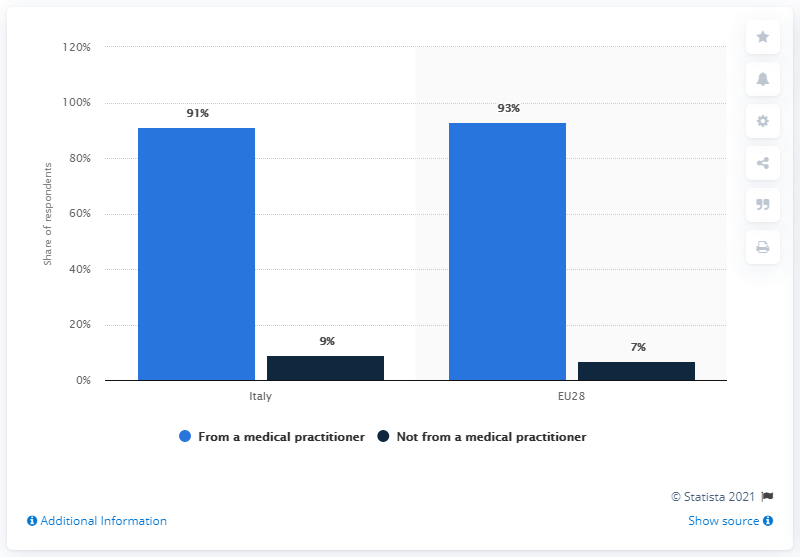List a handful of essential elements in this visual. In Italy, 91% of the population speaks Italian, 9% speaks another language and there is an unknown percentage that speaks another language. In the EU28, 93% of the population speaks only one language and 7% speaks two languages. The ratio of 93% to 7% is 13.29... 